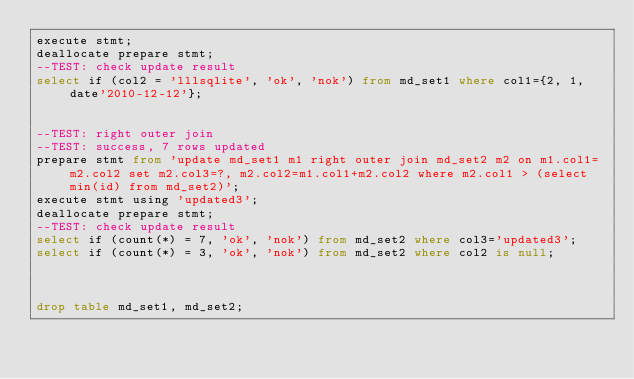Convert code to text. <code><loc_0><loc_0><loc_500><loc_500><_SQL_>execute stmt;
deallocate prepare stmt;
--TEST: check update result
select if (col2 = 'lllsqlite', 'ok', 'nok') from md_set1 where col1={2, 1, date'2010-12-12'};


--TEST: right outer join
--TEST: success, 7 rows updated
prepare stmt from 'update md_set1 m1 right outer join md_set2 m2 on m1.col1=m2.col2 set m2.col3=?, m2.col2=m1.col1+m2.col2 where m2.col1 > (select min(id) from md_set2)';
execute stmt using 'updated3';
deallocate prepare stmt;
--TEST: check update result
select if (count(*) = 7, 'ok', 'nok') from md_set2 where col3='updated3';
select if (count(*) = 3, 'ok', 'nok') from md_set2 where col2 is null;



drop table md_set1, md_set2;






</code> 